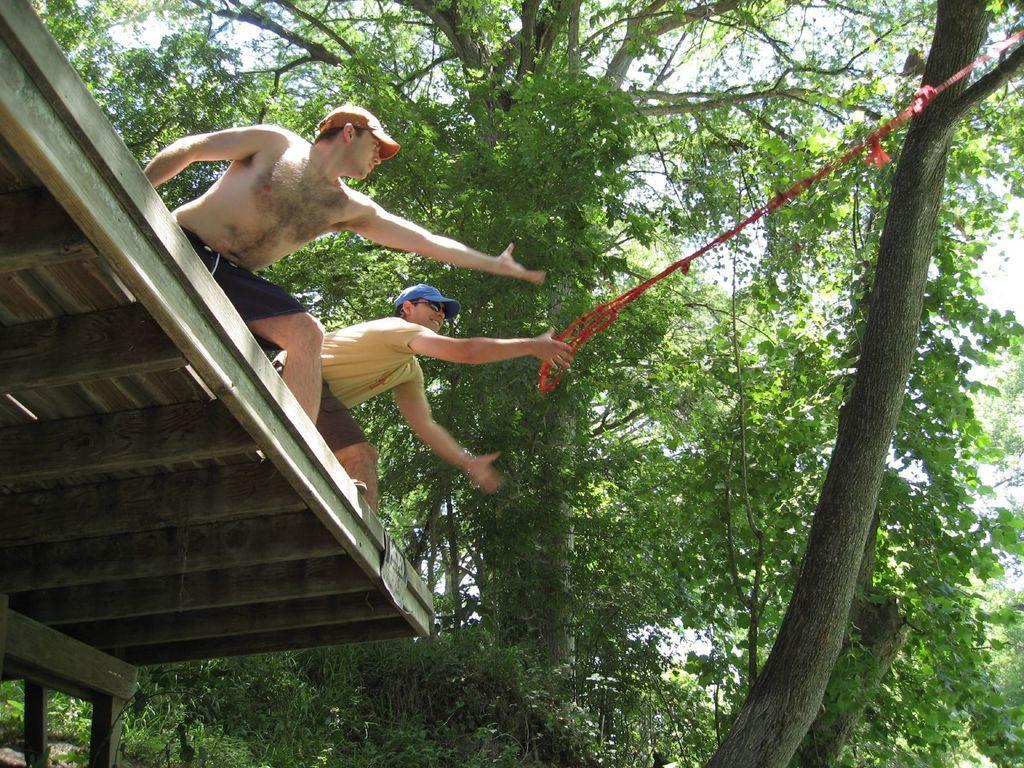Can you describe this image briefly? On the left side of this image I can see two men are standing on the shed and looking at the right side. One person is holding a red color rope which is attached to a tree trunk. In the background there are many trees. 